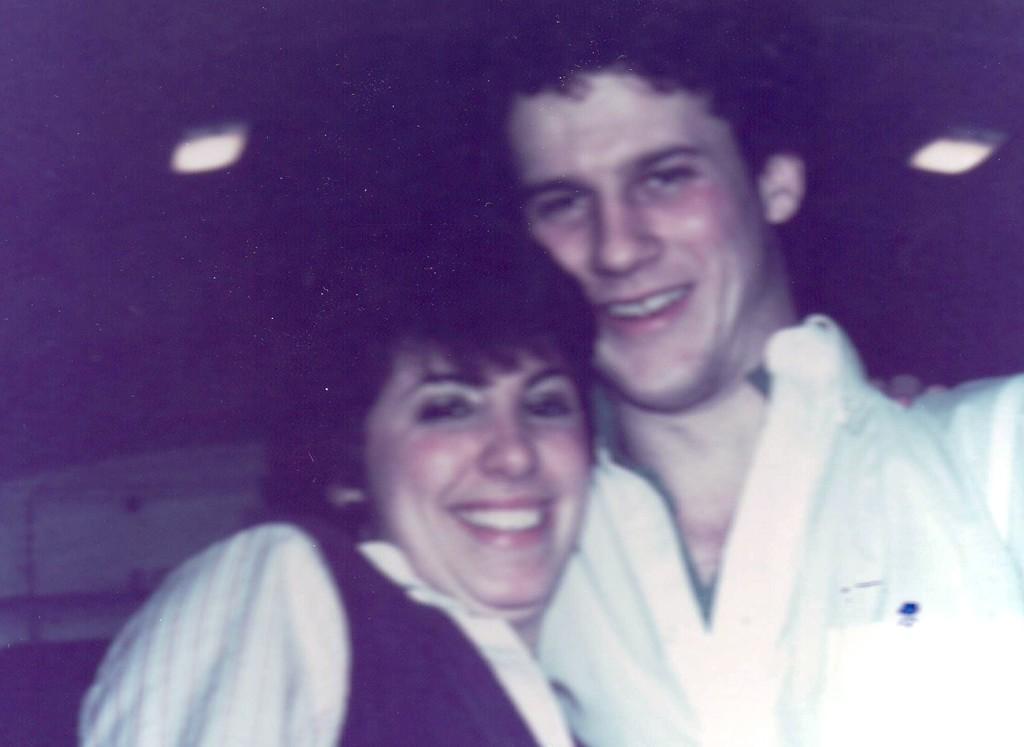Describe this image in one or two sentences. This picture is slightly blurred, where I can see a woman and a man wearing white color dresses are standing here and smiling. The background of the image is dark where we can see ceiling lights. 